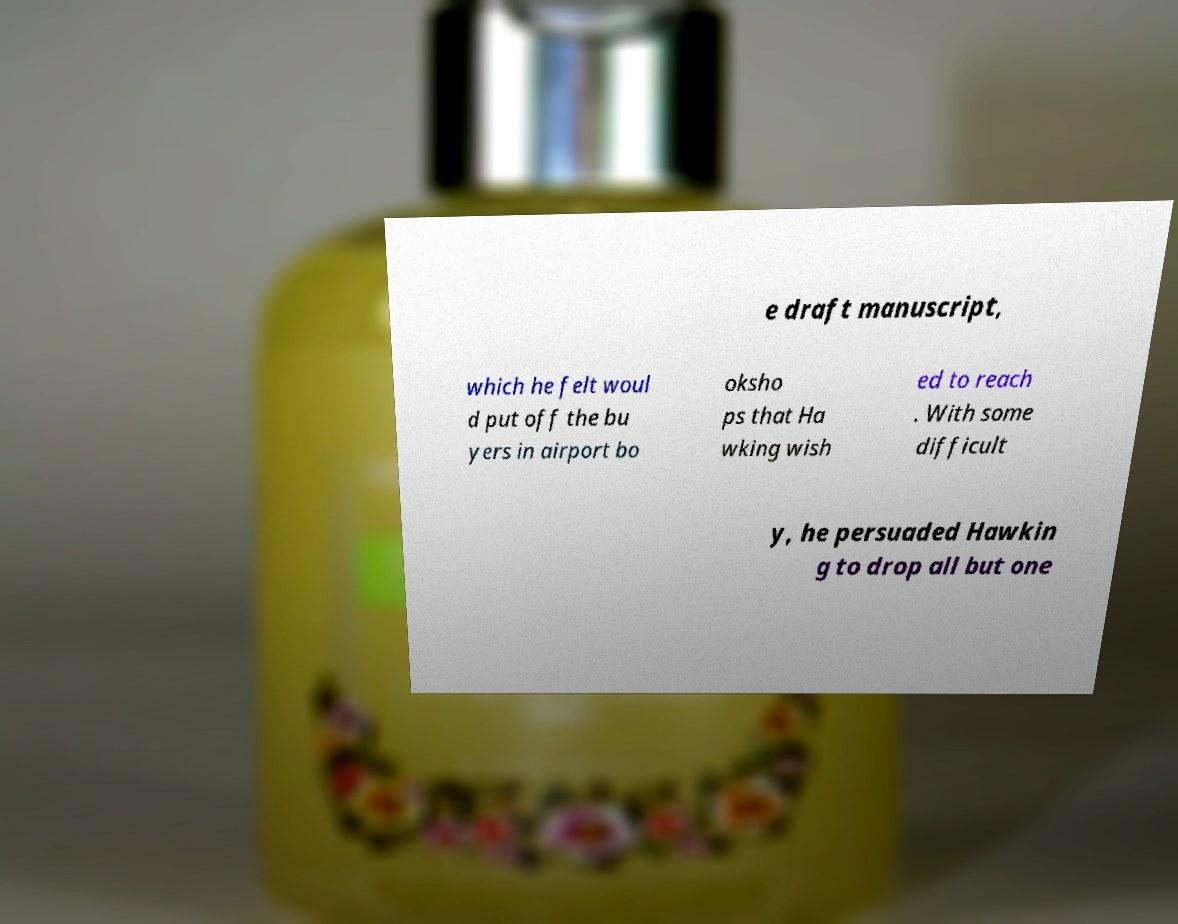Can you read and provide the text displayed in the image?This photo seems to have some interesting text. Can you extract and type it out for me? e draft manuscript, which he felt woul d put off the bu yers in airport bo oksho ps that Ha wking wish ed to reach . With some difficult y, he persuaded Hawkin g to drop all but one 